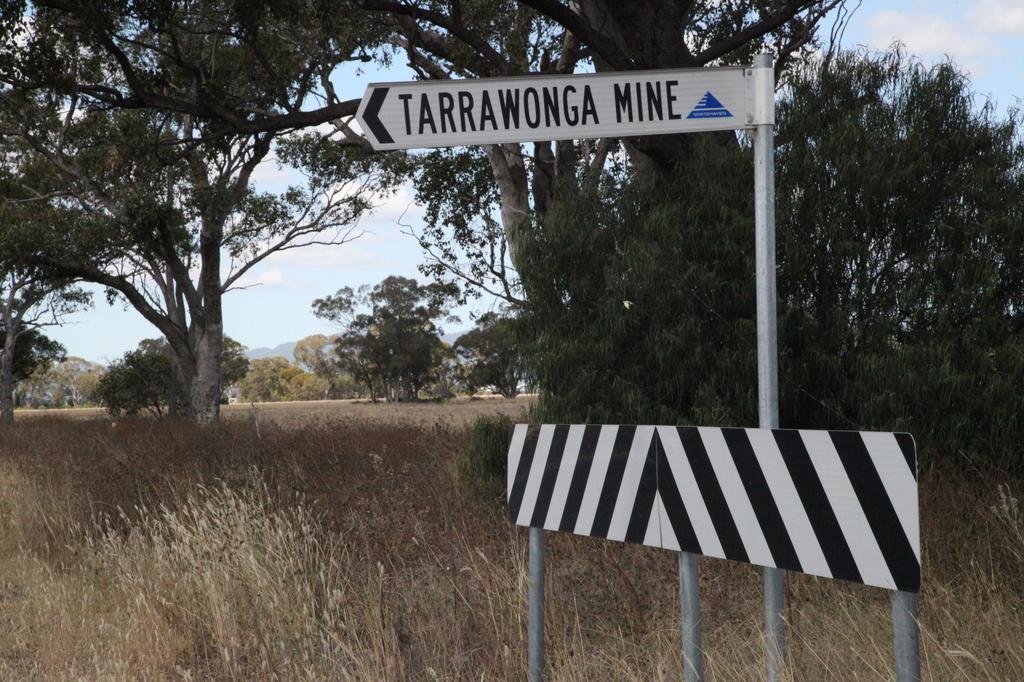In one or two sentences, can you explain what this image depicts? In this image I can see grass, number of trees, clouds, the sky, few poles, few boards and here I can see something is written on this board. 